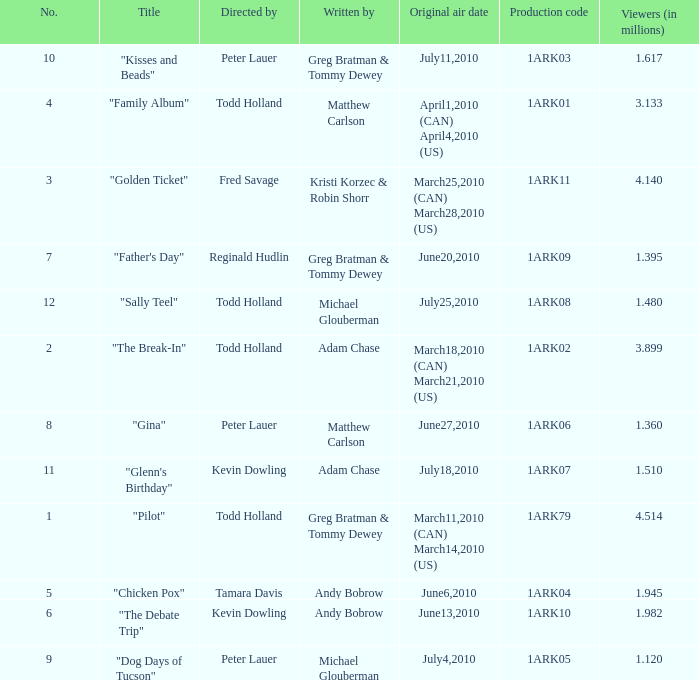How many directors were there for the production code 1ark08? 1.0. 